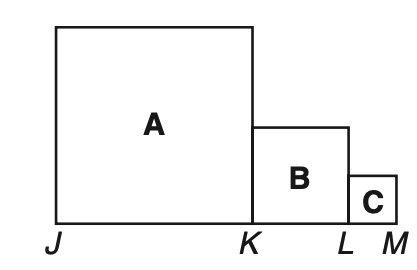Answer the mathemtical geometry problem and directly provide the correct option letter.
Question: In the figure consisting of squares A, B, and C, J K = 2K L and K L = 2L M. If the perimeter of the figure is 66 units, what is the area?
Choices: A: 117 B: 189 C: 224 D: 258 B 